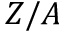Convert formula to latex. <formula><loc_0><loc_0><loc_500><loc_500>Z / A</formula> 